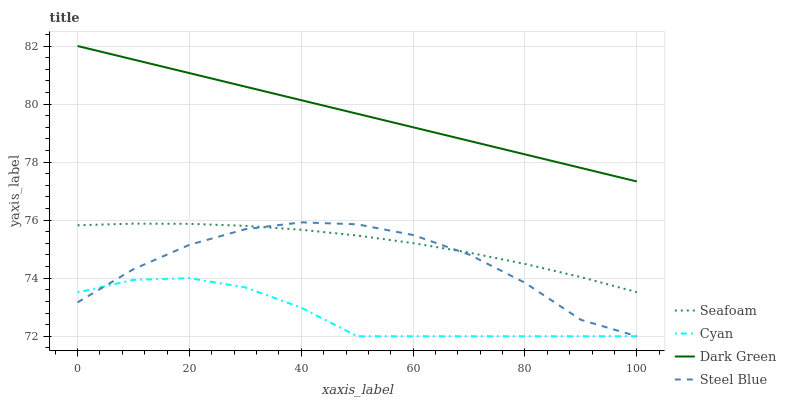Does Cyan have the minimum area under the curve?
Answer yes or no. Yes. Does Dark Green have the maximum area under the curve?
Answer yes or no. Yes. Does Steel Blue have the minimum area under the curve?
Answer yes or no. No. Does Steel Blue have the maximum area under the curve?
Answer yes or no. No. Is Dark Green the smoothest?
Answer yes or no. Yes. Is Steel Blue the roughest?
Answer yes or no. Yes. Is Seafoam the smoothest?
Answer yes or no. No. Is Seafoam the roughest?
Answer yes or no. No. Does Cyan have the lowest value?
Answer yes or no. Yes. Does Seafoam have the lowest value?
Answer yes or no. No. Does Dark Green have the highest value?
Answer yes or no. Yes. Does Steel Blue have the highest value?
Answer yes or no. No. Is Seafoam less than Dark Green?
Answer yes or no. Yes. Is Dark Green greater than Steel Blue?
Answer yes or no. Yes. Does Steel Blue intersect Seafoam?
Answer yes or no. Yes. Is Steel Blue less than Seafoam?
Answer yes or no. No. Is Steel Blue greater than Seafoam?
Answer yes or no. No. Does Seafoam intersect Dark Green?
Answer yes or no. No. 